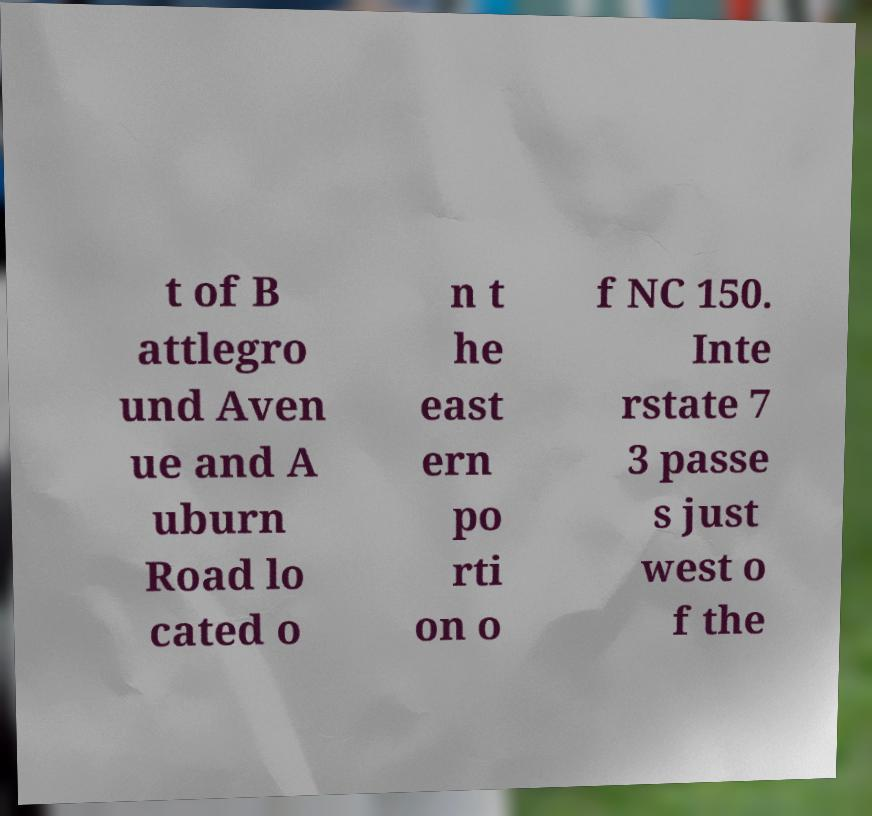Please read and relay the text visible in this image. What does it say? t of B attlegro und Aven ue and A uburn Road lo cated o n t he east ern po rti on o f NC 150. Inte rstate 7 3 passe s just west o f the 